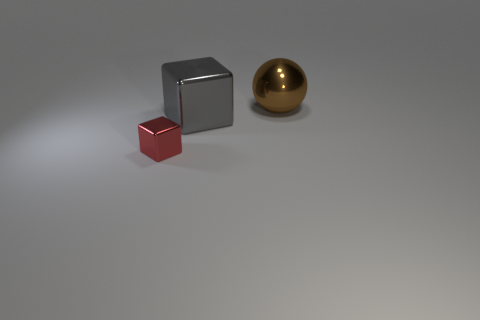Add 3 large cylinders. How many objects exist? 6 Subtract 1 balls. How many balls are left? 0 Subtract 0 brown cubes. How many objects are left? 3 Subtract all cubes. How many objects are left? 1 Subtract all tiny blue rubber things. Subtract all large objects. How many objects are left? 1 Add 2 large gray metallic cubes. How many large gray metallic cubes are left? 3 Add 2 red blocks. How many red blocks exist? 3 